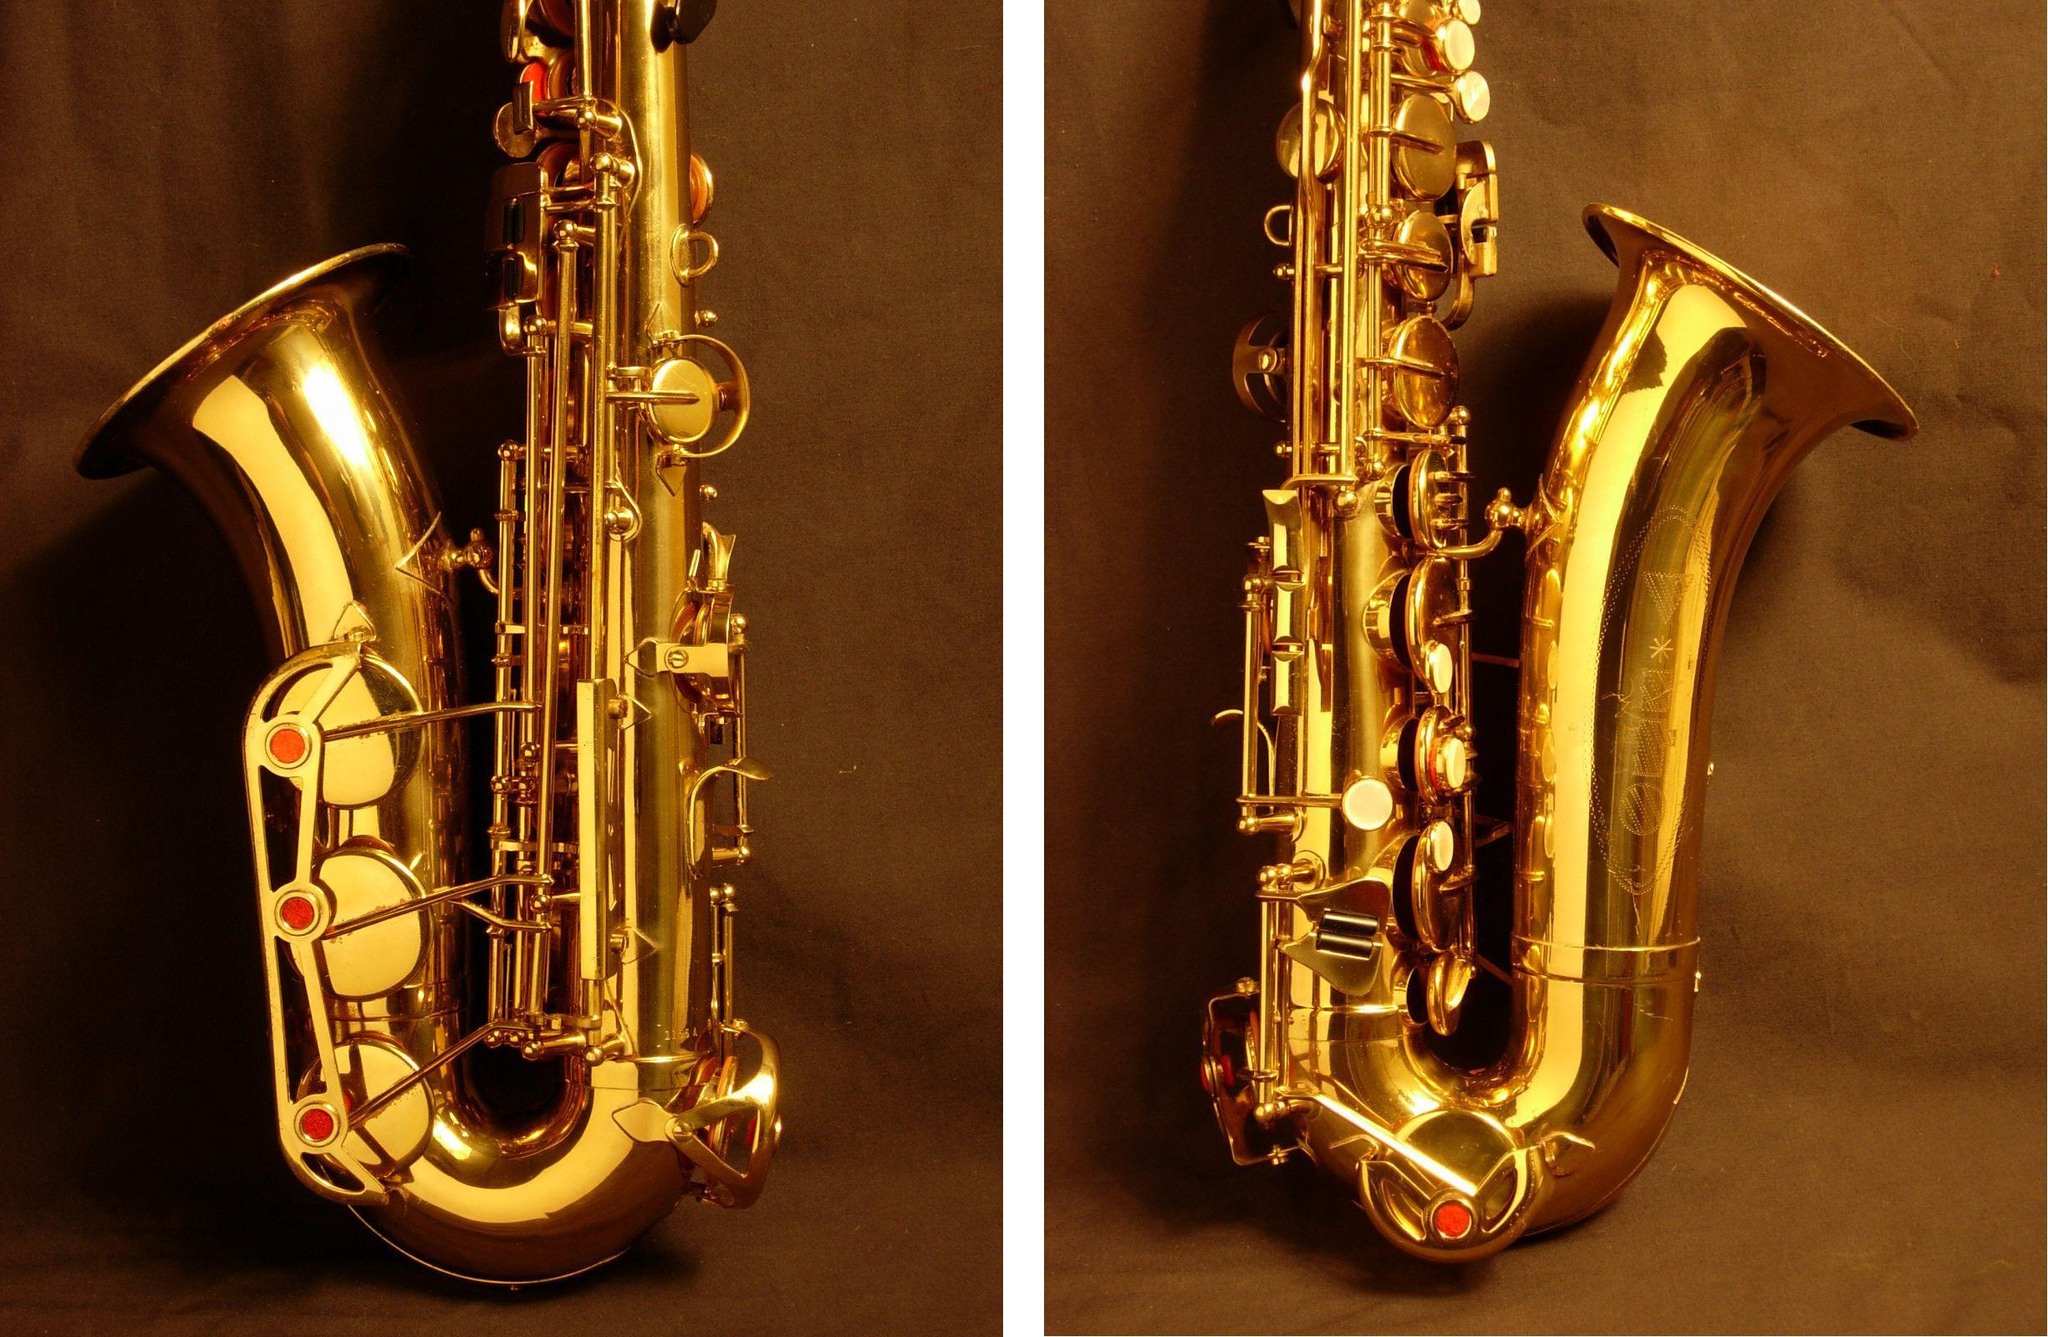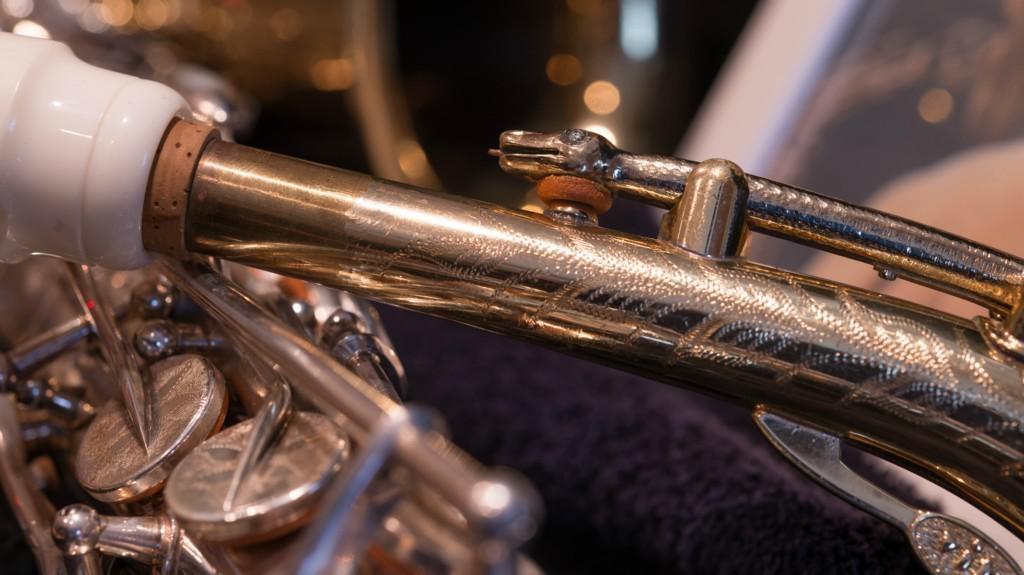The first image is the image on the left, the second image is the image on the right. Considering the images on both sides, is "One image includes the upturned shiny gold bell of at least one saxophone, and the other image shows the etched surface of a saxophone that is more copper colored." valid? Answer yes or no. Yes. The first image is the image on the left, the second image is the image on the right. Examine the images to the left and right. Is the description "Both images contain an engraving on the saxophone that designates where the saxophone was made." accurate? Answer yes or no. No. 